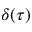Convert formula to latex. <formula><loc_0><loc_0><loc_500><loc_500>\delta ( \tau )</formula> 